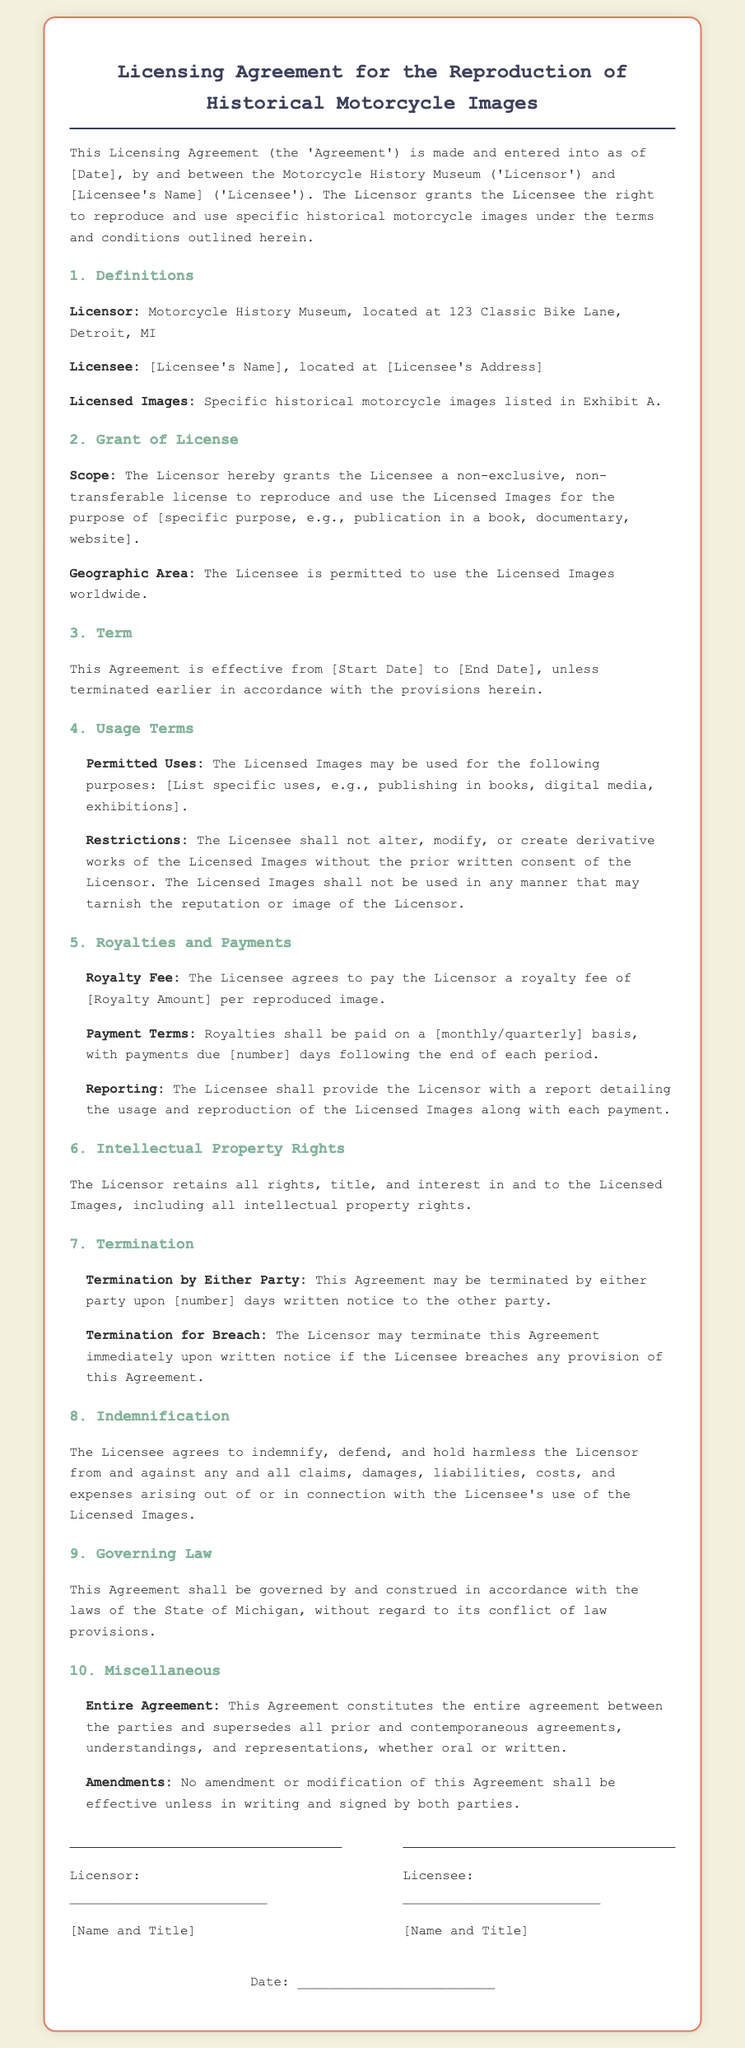What is the name of the Licensor? The Licensor is referred to as the Motorcycle History Museum in the document.
Answer: Motorcycle History Museum Where is the Licensor located? The Licensor's address is provided in the document.
Answer: 123 Classic Bike Lane, Detroit, MI What is the duration of the Agreement? The document specifies the Agreement is effective from Start Date to End Date.
Answer: From [Start Date] to [End Date] How often are royalty payments due? The document mentions the frequency of royalty payments to be monthly or quarterly.
Answer: [monthly/quarterly] What must the Licensee provide along with each payment? A report detailing the usage and reproduction of the Licensed Images must be provided.
Answer: A report detailing the usage What can lead to immediate termination of the Agreement? The Licensor can terminate the Agreement immediately upon written notice if there is a breach.
Answer: Breach of any provision What rights does the Licensor retain? The Licensor retains all rights, title, and interest in the Licensed Images.
Answer: All rights, title, and interest What is the governing law for this Agreement? The governing law specified in the document is related to the State of Michigan.
Answer: State of Michigan What is required for amendments to the Agreement? Amendments must be in writing and signed by both parties to be effective.
Answer: In writing and signed by both parties 